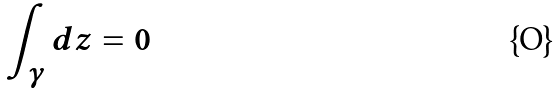<formula> <loc_0><loc_0><loc_500><loc_500>\int _ { \gamma } d z = 0</formula> 